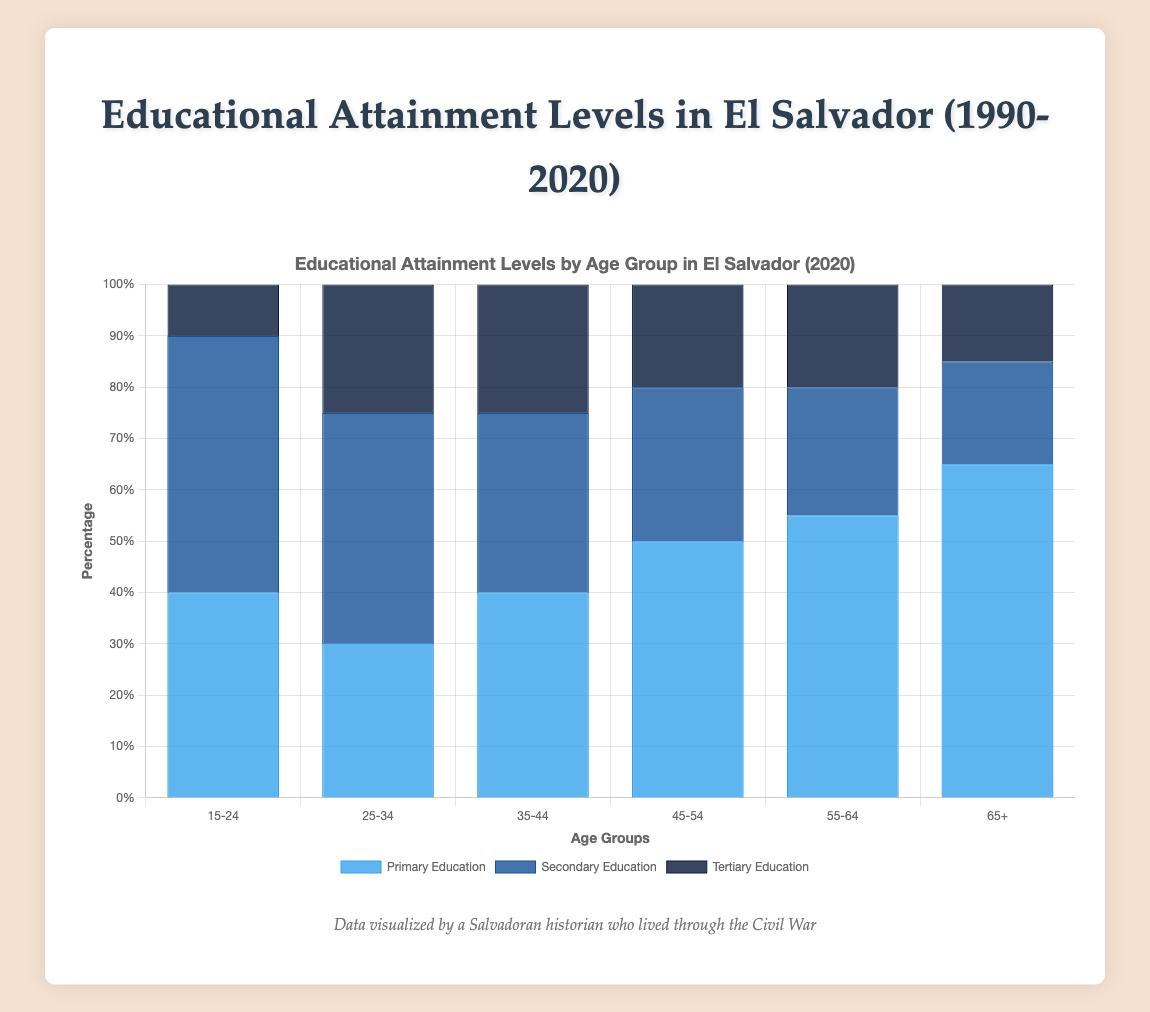What percentage of the 35-44 age group attained secondary education in 2020? To find this, look at the height of the dark blue bar in the 2020 segment under the 35-44 age group, which represents secondary education. The height indicates it is 35%.
Answer: 35% Which age group had the highest percentage of tertiary education in 2020? Look at the topmost sections of the bars representing tertiary education for each age group in 2020. The 25-34 age group has the highest section, which is 25%.
Answer: 25-34 Compare the primary education attainment levels between the 45-54 and 55-64 age groups in 2020. Which is higher? Look at the lengths of the blue sections for 45-54 and 55-64 age groups in 2020. The 45-54 age group is at 50%, and the 55-64 age group is at 55%. The 55-64 group is higher.
Answer: 55-64 What is the sum of tertiary educational attainment across all age groups in 2020? Add the tertiary education percentages from all age groups for 2020: 10% (15-24) + 25% (25-34) + 25% (35-44) + 20% (45-54) + 20% (55-64) + 15% (65+). This totals to 115%.
Answer: 115% What trend in secondary education attainment is observable from 1990 to 2020 across the 15-24 age group? Observe how the dark blue bar in the 15-24 age group segments progresses from 1990 (20%) to 2020 (50%). There is a clear increasing trend.
Answer: Increasing trend By how much did the secondary education attainment level (in percentage points) for the 25-34 age group increase from 1990 to 2020? Subtract the 1990 secondary education percentage (30%) for 25-34 from the 2020 percentage (45%). This results in an increase of 15 percentage points.
Answer: 15 percentage points Which age group showed the most significant improvement in tertiary education attainment from 1990 to 2020? Compare the increase in tertiary education from 1990 to 2020 across all age groups. The 25-34 group increased from 10% (1990) to 25% (2020), a 15 percentage point increase, which is the highest improvement.
Answer: 25-34 What is the average tertiary education attainment level across all age groups in 2020? Sum the tertiary education percentages for all age groups in 2020: 10%, 25%, 25%, 20%, 20%, and 15%, then divide by the number of age groups (6). The calculation is (10 + 25 + 25 + 20 + 20 + 15)/6 = 115/6 ≈ 19.17%.
Answer: 19.17% Overall, did primary education attainment levels decrease or increase from 1990 to 2020 for age groups 45-54 and older? For both 45-54 and 55-64 age groups: 45-54 decreased from 80% to 50%, and 55-64 decreased from 85% to 55%. Both age groups show a decrease.
Answer: Decrease 